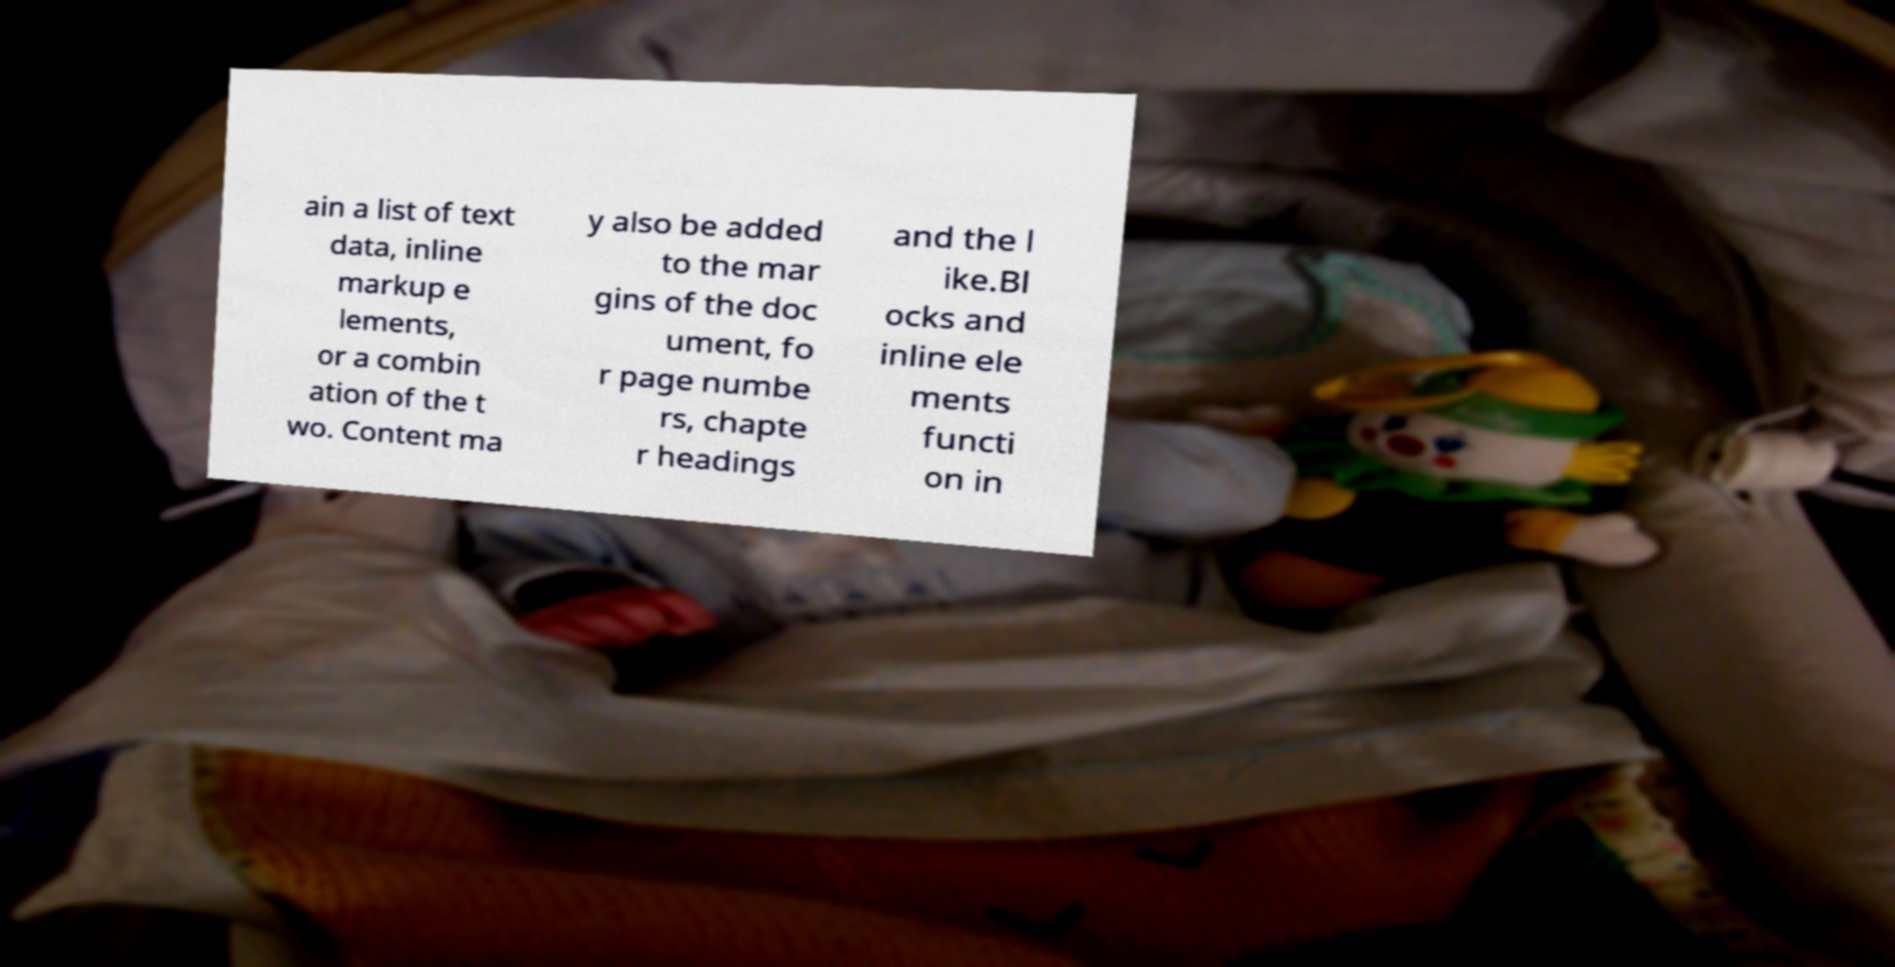There's text embedded in this image that I need extracted. Can you transcribe it verbatim? ain a list of text data, inline markup e lements, or a combin ation of the t wo. Content ma y also be added to the mar gins of the doc ument, fo r page numbe rs, chapte r headings and the l ike.Bl ocks and inline ele ments functi on in 